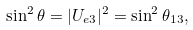Convert formula to latex. <formula><loc_0><loc_0><loc_500><loc_500>\sin ^ { 2 } \theta = | U _ { e 3 } | ^ { 2 } = \sin ^ { 2 } \theta _ { 1 3 } ,</formula> 